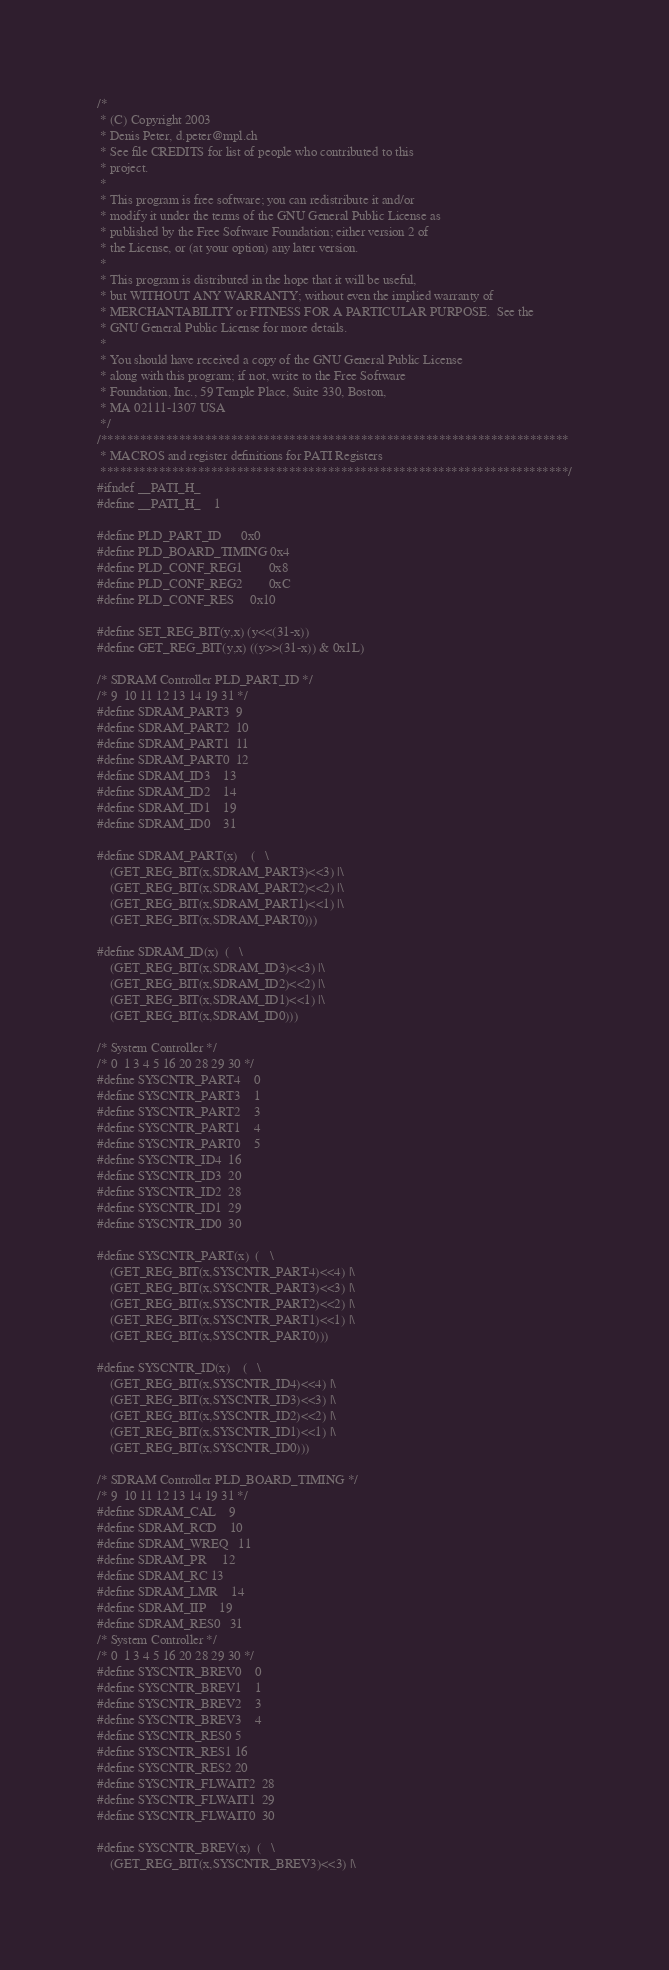Convert code to text. <code><loc_0><loc_0><loc_500><loc_500><_C_>/*
 * (C) Copyright 2003
 * Denis Peter, d.peter@mpl.ch
 * See file CREDITS for list of people who contributed to this
 * project.
 *
 * This program is free software; you can redistribute it and/or
 * modify it under the terms of the GNU General Public License as
 * published by the Free Software Foundation; either version 2 of
 * the License, or (at your option) any later version.
 *
 * This program is distributed in the hope that it will be useful,
 * but WITHOUT ANY WARRANTY; without even the implied warranty of
 * MERCHANTABILITY or FITNESS FOR A PARTICULAR PURPOSE.  See the
 * GNU General Public License for more details.
 *
 * You should have received a copy of the GNU General Public License
 * along with this program; if not, write to the Free Software
 * Foundation, Inc., 59 Temple Place, Suite 330, Boston,
 * MA 02111-1307 USA
 */
/************************************************************************
 * MACROS and register definitions for PATI Registers
 ************************************************************************/
#ifndef __PATI_H_
#define __PATI_H_	1

#define PLD_PART_ID		0x0
#define PLD_BOARD_TIMING	0x4
#define PLD_CONF_REG1		0x8
#define PLD_CONF_REG2		0xC
#define PLD_CONF_RES		0x10

#define SET_REG_BIT(y,x) (y<<(31-x))
#define GET_REG_BIT(y,x) ((y>>(31-x)) & 0x1L)

/* SDRAM Controller PLD_PART_ID */
/* 9  10 11 12 13 14 19 31 */
#define SDRAM_PART3	9
#define SDRAM_PART2	10
#define SDRAM_PART1	11
#define SDRAM_PART0	12
#define SDRAM_ID3	13
#define SDRAM_ID2	14
#define SDRAM_ID1	19
#define SDRAM_ID0	31

#define SDRAM_PART(x)	(	\
	(GET_REG_BIT(x,SDRAM_PART3)<<3) |\
	(GET_REG_BIT(x,SDRAM_PART2)<<2) |\
	(GET_REG_BIT(x,SDRAM_PART1)<<1) |\
	(GET_REG_BIT(x,SDRAM_PART0)))

#define SDRAM_ID(x)	(	\
	(GET_REG_BIT(x,SDRAM_ID3)<<3) |\
	(GET_REG_BIT(x,SDRAM_ID2)<<2) |\
	(GET_REG_BIT(x,SDRAM_ID1)<<1) |\
	(GET_REG_BIT(x,SDRAM_ID0)))

/* System Controller */
/* 0  1 3 4 5 16 20 28 29 30 */
#define SYSCNTR_PART4	0
#define SYSCNTR_PART3	1
#define SYSCNTR_PART2	3
#define SYSCNTR_PART1	4
#define SYSCNTR_PART0	5
#define SYSCNTR_ID4	16
#define SYSCNTR_ID3	20
#define SYSCNTR_ID2	28
#define SYSCNTR_ID1	29
#define SYSCNTR_ID0	30

#define SYSCNTR_PART(x)	(	\
	(GET_REG_BIT(x,SYSCNTR_PART4)<<4) |\
	(GET_REG_BIT(x,SYSCNTR_PART3)<<3) |\
	(GET_REG_BIT(x,SYSCNTR_PART2)<<2) |\
	(GET_REG_BIT(x,SYSCNTR_PART1)<<1) |\
	(GET_REG_BIT(x,SYSCNTR_PART0)))

#define SYSCNTR_ID(x)	(	\
	(GET_REG_BIT(x,SYSCNTR_ID4)<<4) |\
	(GET_REG_BIT(x,SYSCNTR_ID3)<<3) |\
	(GET_REG_BIT(x,SYSCNTR_ID2)<<2) |\
	(GET_REG_BIT(x,SYSCNTR_ID1)<<1) |\
	(GET_REG_BIT(x,SYSCNTR_ID0)))

/* SDRAM Controller PLD_BOARD_TIMING */
/* 9  10 11 12 13 14 19 31 */
#define SDRAM_CAL	9
#define SDRAM_RCD	10
#define SDRAM_WREQ	11
#define SDRAM_PR 	12
#define SDRAM_RC	13
#define SDRAM_LMR	14
#define SDRAM_IIP	19
#define SDRAM_RES0	31
/* System Controller */
/* 0  1 3 4 5 16 20 28 29 30 */
#define SYSCNTR_BREV0	0
#define SYSCNTR_BREV1	1
#define SYSCNTR_BREV2	3
#define SYSCNTR_BREV3	4
#define SYSCNTR_RES0	5
#define SYSCNTR_RES1	16
#define SYSCNTR_RES2	20
#define SYSCNTR_FLWAIT2	28
#define SYSCNTR_FLWAIT1	29
#define SYSCNTR_FLWAIT0	30

#define SYSCNTR_BREV(x)	(	\
	(GET_REG_BIT(x,SYSCNTR_BREV3)<<3) |\</code> 